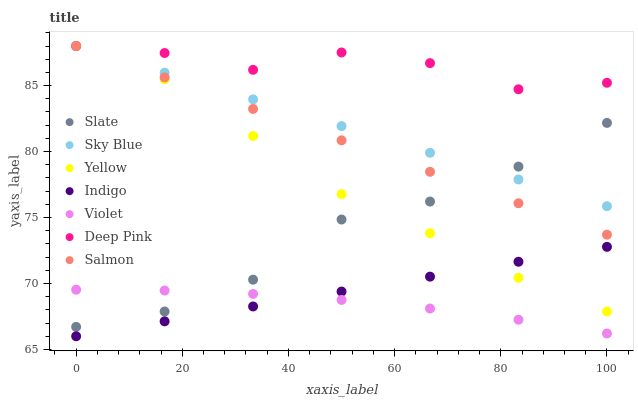Does Violet have the minimum area under the curve?
Answer yes or no. Yes. Does Deep Pink have the maximum area under the curve?
Answer yes or no. Yes. Does Indigo have the minimum area under the curve?
Answer yes or no. No. Does Indigo have the maximum area under the curve?
Answer yes or no. No. Is Sky Blue the smoothest?
Answer yes or no. Yes. Is Deep Pink the roughest?
Answer yes or no. Yes. Is Indigo the smoothest?
Answer yes or no. No. Is Indigo the roughest?
Answer yes or no. No. Does Indigo have the lowest value?
Answer yes or no. Yes. Does Slate have the lowest value?
Answer yes or no. No. Does Sky Blue have the highest value?
Answer yes or no. Yes. Does Indigo have the highest value?
Answer yes or no. No. Is Indigo less than Slate?
Answer yes or no. Yes. Is Yellow greater than Violet?
Answer yes or no. Yes. Does Salmon intersect Sky Blue?
Answer yes or no. Yes. Is Salmon less than Sky Blue?
Answer yes or no. No. Is Salmon greater than Sky Blue?
Answer yes or no. No. Does Indigo intersect Slate?
Answer yes or no. No. 